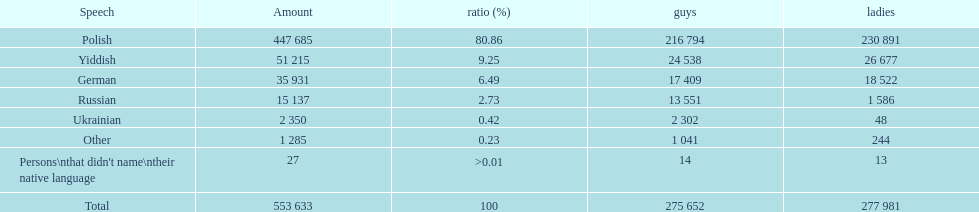Which language did the most people in the imperial census of 1897 speak in the p&#322;ock governorate? Polish. 